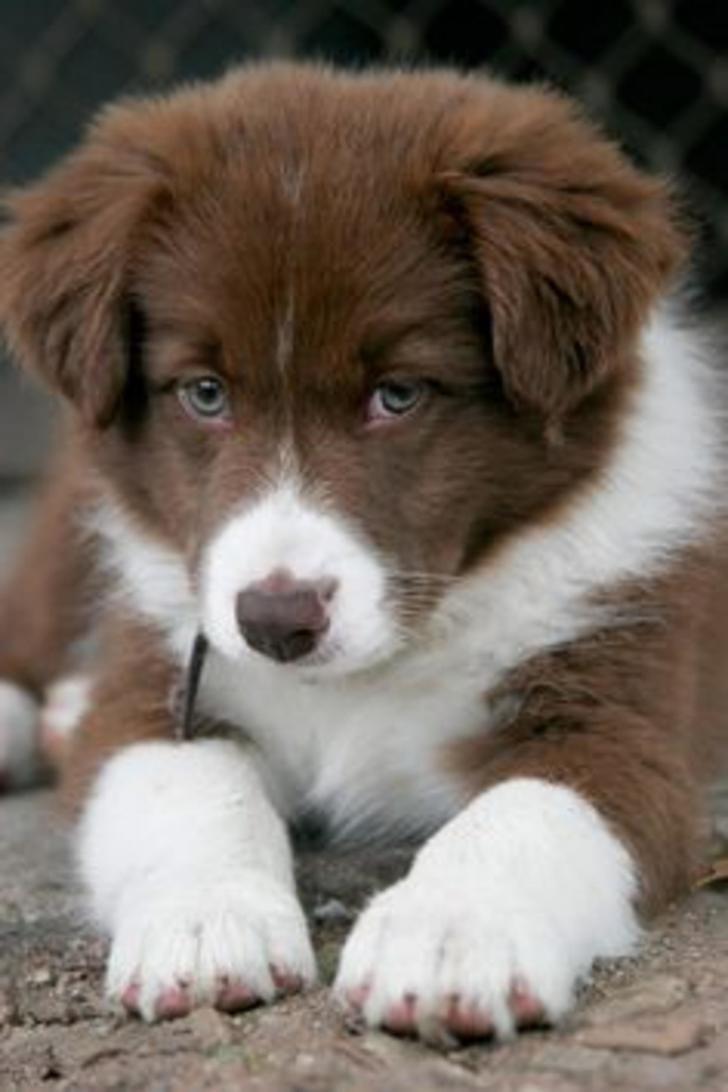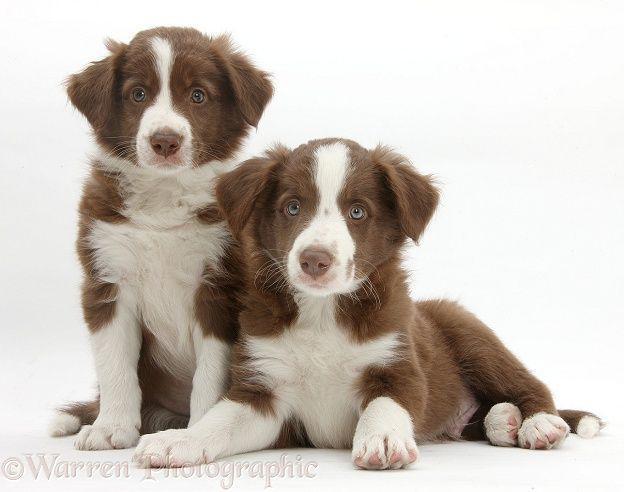The first image is the image on the left, the second image is the image on the right. Assess this claim about the two images: "One brown and white dog has its mouth open with tongue showing and one does not, but both have wide white bands of color between their eyes.". Correct or not? Answer yes or no. No. The first image is the image on the left, the second image is the image on the right. Considering the images on both sides, is "The combined images include two brown-and-white dogs reclining with front paws extended forward." valid? Answer yes or no. Yes. 